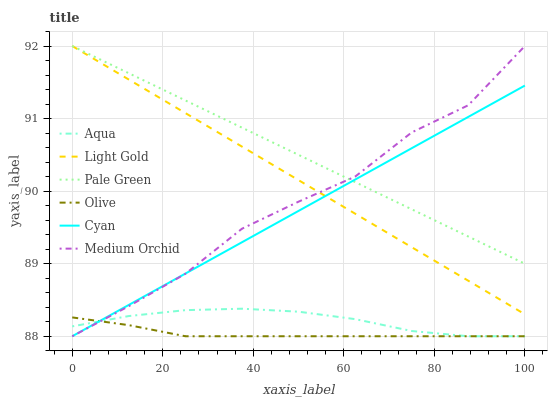Does Olive have the minimum area under the curve?
Answer yes or no. Yes. Does Pale Green have the maximum area under the curve?
Answer yes or no. Yes. Does Aqua have the minimum area under the curve?
Answer yes or no. No. Does Aqua have the maximum area under the curve?
Answer yes or no. No. Is Pale Green the smoothest?
Answer yes or no. Yes. Is Medium Orchid the roughest?
Answer yes or no. Yes. Is Aqua the smoothest?
Answer yes or no. No. Is Aqua the roughest?
Answer yes or no. No. Does Medium Orchid have the lowest value?
Answer yes or no. Yes. Does Pale Green have the lowest value?
Answer yes or no. No. Does Light Gold have the highest value?
Answer yes or no. Yes. Does Aqua have the highest value?
Answer yes or no. No. Is Olive less than Light Gold?
Answer yes or no. Yes. Is Pale Green greater than Aqua?
Answer yes or no. Yes. Does Pale Green intersect Light Gold?
Answer yes or no. Yes. Is Pale Green less than Light Gold?
Answer yes or no. No. Is Pale Green greater than Light Gold?
Answer yes or no. No. Does Olive intersect Light Gold?
Answer yes or no. No. 